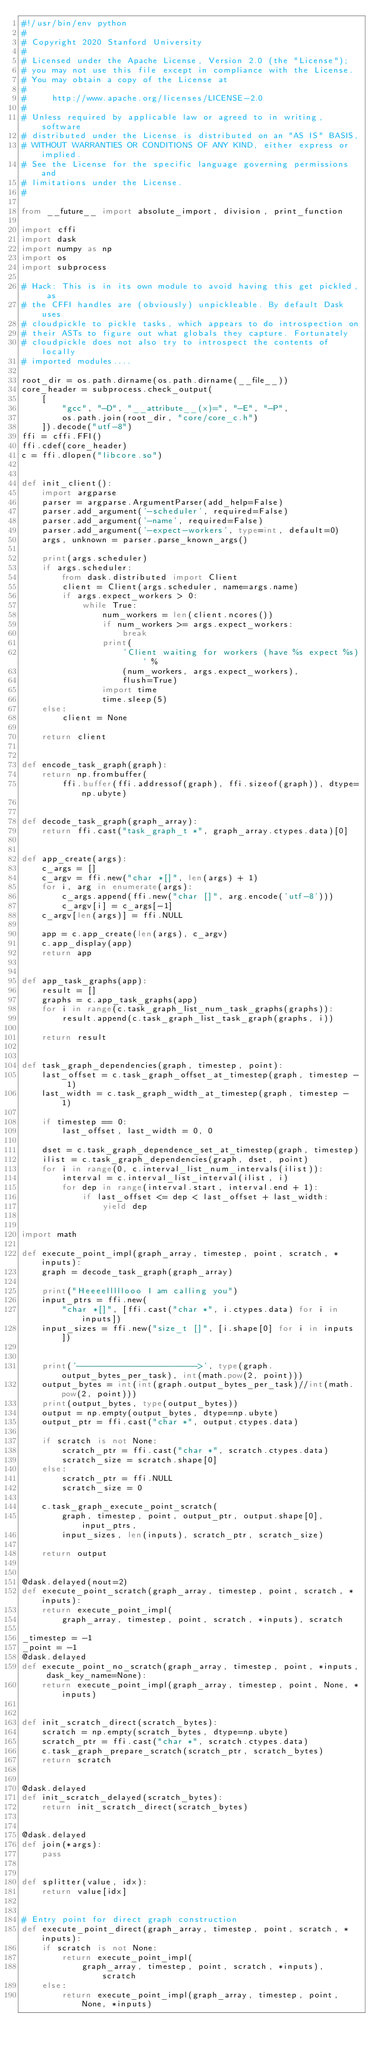Convert code to text. <code><loc_0><loc_0><loc_500><loc_500><_Python_>#!/usr/bin/env python
#
# Copyright 2020 Stanford University
#
# Licensed under the Apache License, Version 2.0 (the "License");
# you may not use this file except in compliance with the License.
# You may obtain a copy of the License at
#
#     http://www.apache.org/licenses/LICENSE-2.0
#
# Unless required by applicable law or agreed to in writing, software
# distributed under the License is distributed on an "AS IS" BASIS,
# WITHOUT WARRANTIES OR CONDITIONS OF ANY KIND, either express or implied.
# See the License for the specific language governing permissions and
# limitations under the License.
#

from __future__ import absolute_import, division, print_function

import cffi
import dask
import numpy as np
import os
import subprocess

# Hack: This is in its own module to avoid having this get pickled, as
# the CFFI handles are (obviously) unpickleable. By default Dask uses
# cloudpickle to pickle tasks, which appears to do introspection on
# their ASTs to figure out what globals they capture. Fortunately
# cloudpickle does not also try to introspect the contents of locally
# imported modules....

root_dir = os.path.dirname(os.path.dirname(__file__))
core_header = subprocess.check_output(
    [
        "gcc", "-D", "__attribute__(x)=", "-E", "-P",
        os.path.join(root_dir, "core/core_c.h")
    ]).decode("utf-8")
ffi = cffi.FFI()
ffi.cdef(core_header)
c = ffi.dlopen("libcore.so")


def init_client():
    import argparse
    parser = argparse.ArgumentParser(add_help=False)
    parser.add_argument('-scheduler', required=False)
    parser.add_argument('-name', required=False)
    parser.add_argument('-expect-workers', type=int, default=0)
    args, unknown = parser.parse_known_args()

    print(args.scheduler)
    if args.scheduler:
        from dask.distributed import Client
        client = Client(args.scheduler, name=args.name)
        if args.expect_workers > 0:
            while True:
                num_workers = len(client.ncores())
                if num_workers >= args.expect_workers:
                    break
                print(
                    'Client waiting for workers (have %s expect %s)' %
                    (num_workers, args.expect_workers),
                    flush=True)
                import time
                time.sleep(5)
    else:
        client = None

    return client


def encode_task_graph(graph):
    return np.frombuffer(
        ffi.buffer(ffi.addressof(graph), ffi.sizeof(graph)), dtype=np.ubyte)


def decode_task_graph(graph_array):
    return ffi.cast("task_graph_t *", graph_array.ctypes.data)[0]


def app_create(args):
    c_args = []
    c_argv = ffi.new("char *[]", len(args) + 1)
    for i, arg in enumerate(args):
        c_args.append(ffi.new("char []", arg.encode('utf-8')))
        c_argv[i] = c_args[-1]
    c_argv[len(args)] = ffi.NULL

    app = c.app_create(len(args), c_argv)
    c.app_display(app)
    return app


def app_task_graphs(app):
    result = []
    graphs = c.app_task_graphs(app)
    for i in range(c.task_graph_list_num_task_graphs(graphs)):
        result.append(c.task_graph_list_task_graph(graphs, i))

    return result


def task_graph_dependencies(graph, timestep, point):
    last_offset = c.task_graph_offset_at_timestep(graph, timestep - 1)
    last_width = c.task_graph_width_at_timestep(graph, timestep - 1)

    if timestep == 0:
        last_offset, last_width = 0, 0

    dset = c.task_graph_dependence_set_at_timestep(graph, timestep)
    ilist = c.task_graph_dependencies(graph, dset, point)
    for i in range(0, c.interval_list_num_intervals(ilist)):
        interval = c.interval_list_interval(ilist, i)
        for dep in range(interval.start, interval.end + 1):
            if last_offset <= dep < last_offset + last_width:
                yield dep


import math 

def execute_point_impl(graph_array, timestep, point, scratch, *inputs):
    graph = decode_task_graph(graph_array)

    print("Heeeelllllooo I am calling you")
    input_ptrs = ffi.new(
        "char *[]", [ffi.cast("char *", i.ctypes.data) for i in inputs])
    input_sizes = ffi.new("size_t []", [i.shape[0] for i in inputs])
    

    print('------------------------>', type(graph.output_bytes_per_task), int(math.pow(2, point)))
    output_bytes = int(int(graph.output_bytes_per_task)//int(math.pow(2, point)))
    print(output_bytes, type(output_bytes))
    output = np.empty(output_bytes, dtype=np.ubyte)
    output_ptr = ffi.cast("char *", output.ctypes.data)

    if scratch is not None:
        scratch_ptr = ffi.cast("char *", scratch.ctypes.data)
        scratch_size = scratch.shape[0]
    else:
        scratch_ptr = ffi.NULL
        scratch_size = 0

    c.task_graph_execute_point_scratch(
        graph, timestep, point, output_ptr, output.shape[0], input_ptrs,
        input_sizes, len(inputs), scratch_ptr, scratch_size)

    return output


@dask.delayed(nout=2)
def execute_point_scratch(graph_array, timestep, point, scratch, *inputs):
    return execute_point_impl(
        graph_array, timestep, point, scratch, *inputs), scratch

_timestep = -1
_point = -1
@dask.delayed
def execute_point_no_scratch(graph_array, timestep, point, *inputs, dask_key_name=None):
    return execute_point_impl(graph_array, timestep, point, None, *inputs)


def init_scratch_direct(scratch_bytes):
    scratch = np.empty(scratch_bytes, dtype=np.ubyte)
    scratch_ptr = ffi.cast("char *", scratch.ctypes.data)
    c.task_graph_prepare_scratch(scratch_ptr, scratch_bytes)
    return scratch


@dask.delayed
def init_scratch_delayed(scratch_bytes):
    return init_scratch_direct(scratch_bytes)


@dask.delayed
def join(*args):
    pass


def splitter(value, idx):
    return value[idx]


# Entry point for direct graph construction
def execute_point_direct(graph_array, timestep, point, scratch, *inputs):
    if scratch is not None:
        return execute_point_impl(
            graph_array, timestep, point, scratch, *inputs), scratch
    else:
        return execute_point_impl(graph_array, timestep, point, None, *inputs)

</code> 